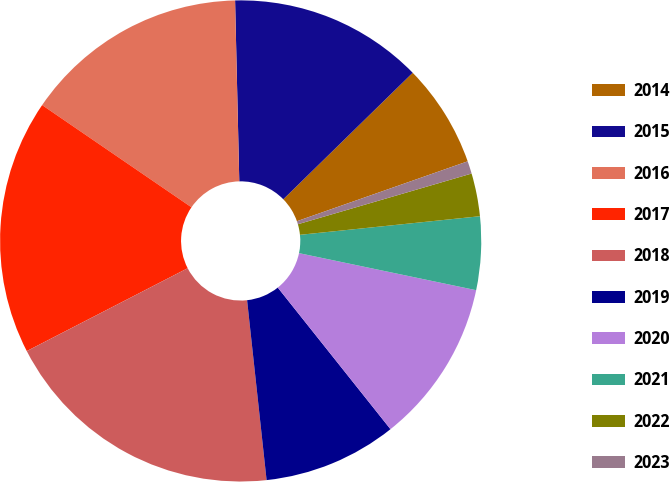<chart> <loc_0><loc_0><loc_500><loc_500><pie_chart><fcel>2014<fcel>2015<fcel>2016<fcel>2017<fcel>2018<fcel>2019<fcel>2020<fcel>2021<fcel>2022<fcel>2023<nl><fcel>6.95%<fcel>13.05%<fcel>15.08%<fcel>17.12%<fcel>19.15%<fcel>8.98%<fcel>11.02%<fcel>4.92%<fcel>2.88%<fcel>0.85%<nl></chart> 